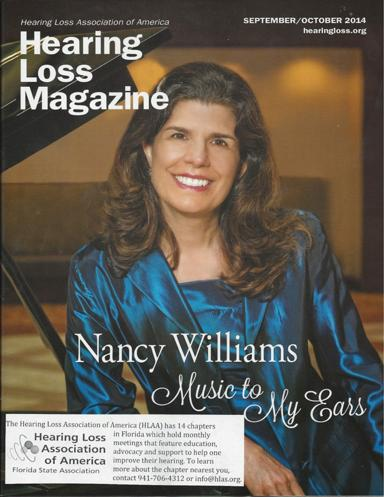What is the name of the magazine mentioned in the image? The magazine featured in the image is 'Hearing Loss Magazine,' a publication dedicated to providing insights, news, and support related to hearing loss. 